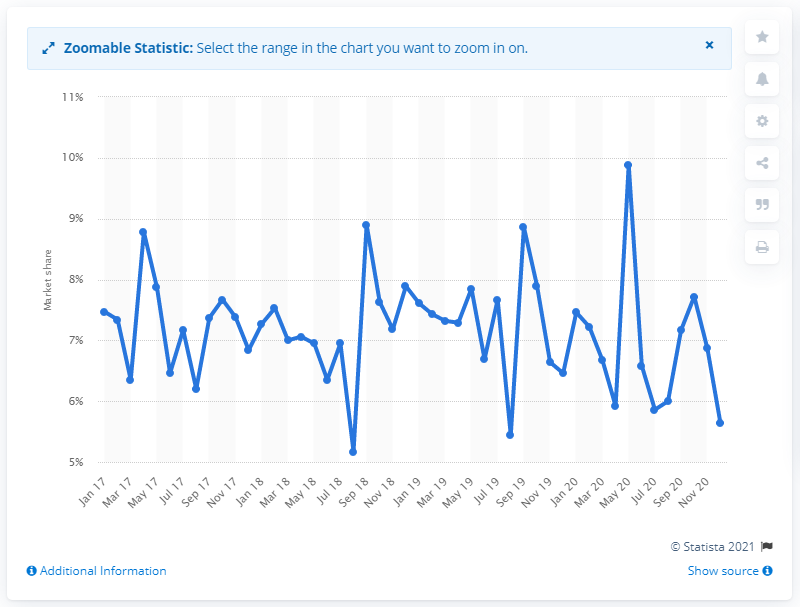Mention a couple of crucial points in this snapshot. In May 2020, Mercedes-Benz accounted for 9.89% of the total UK market. 